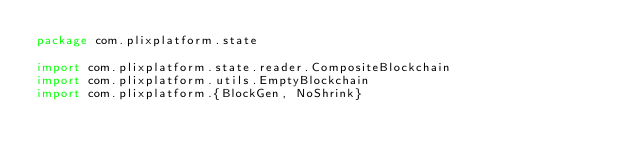Convert code to text. <code><loc_0><loc_0><loc_500><loc_500><_Scala_>package com.plixplatform.state

import com.plixplatform.state.reader.CompositeBlockchain
import com.plixplatform.utils.EmptyBlockchain
import com.plixplatform.{BlockGen, NoShrink}</code> 